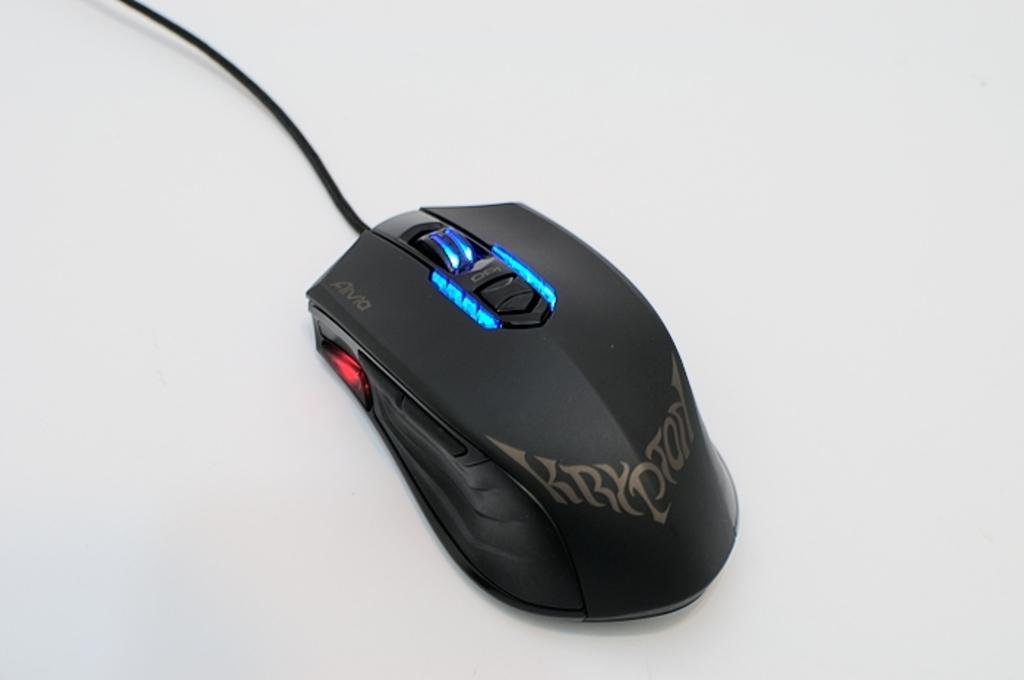<image>
Present a compact description of the photo's key features. A black corded device which looks like a mouse and has "Krypton" in silver letters. 